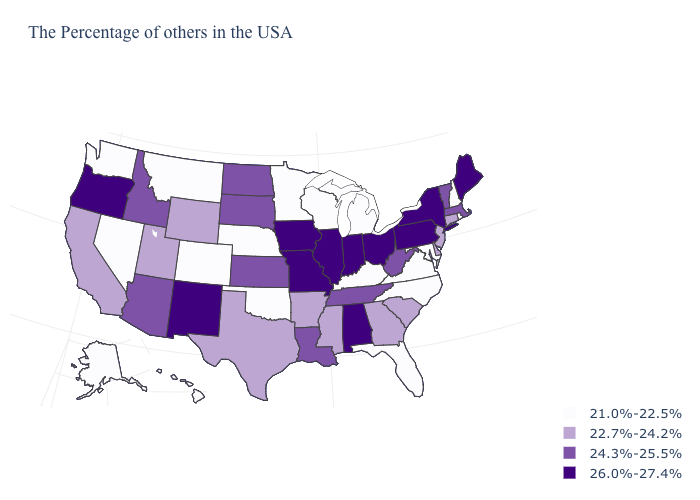What is the value of Idaho?
Give a very brief answer. 24.3%-25.5%. Among the states that border South Carolina , does Georgia have the highest value?
Write a very short answer. Yes. How many symbols are there in the legend?
Keep it brief. 4. Does Oklahoma have the lowest value in the South?
Quick response, please. Yes. What is the value of Mississippi?
Concise answer only. 22.7%-24.2%. What is the value of California?
Keep it brief. 22.7%-24.2%. What is the value of Minnesota?
Keep it brief. 21.0%-22.5%. Name the states that have a value in the range 26.0%-27.4%?
Answer briefly. Maine, New York, Pennsylvania, Ohio, Indiana, Alabama, Illinois, Missouri, Iowa, New Mexico, Oregon. What is the lowest value in the South?
Concise answer only. 21.0%-22.5%. Does Mississippi have the highest value in the USA?
Write a very short answer. No. Is the legend a continuous bar?
Be succinct. No. What is the value of New York?
Write a very short answer. 26.0%-27.4%. What is the value of North Carolina?
Keep it brief. 21.0%-22.5%. What is the highest value in the Northeast ?
Write a very short answer. 26.0%-27.4%. 